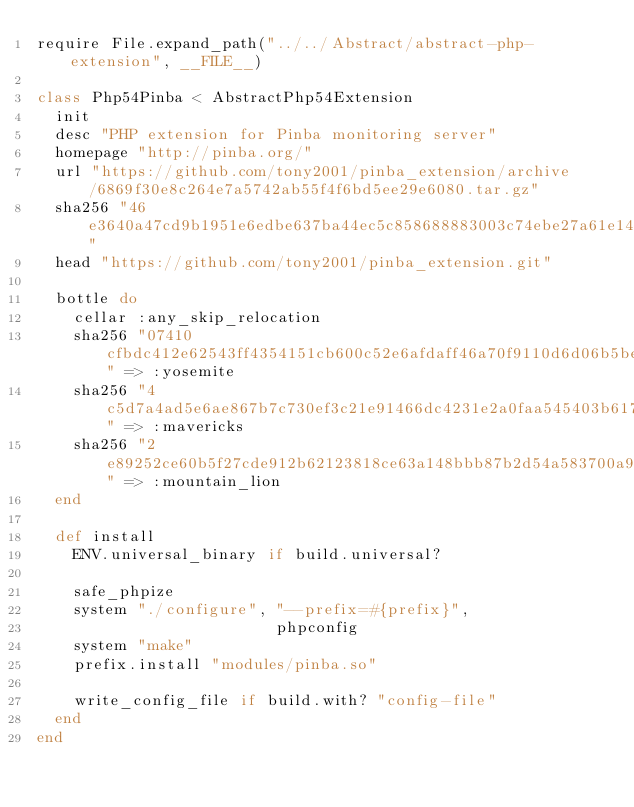<code> <loc_0><loc_0><loc_500><loc_500><_Ruby_>require File.expand_path("../../Abstract/abstract-php-extension", __FILE__)

class Php54Pinba < AbstractPhp54Extension
  init
  desc "PHP extension for Pinba monitoring server"
  homepage "http://pinba.org/"
  url "https://github.com/tony2001/pinba_extension/archive/6869f30e8c264e7a5742ab55f4f6bd5ee29e6080.tar.gz"
  sha256 "46e3640a47cd9b1951e6edbe637ba44ec5c858688883003c74ebe27a61e14fc5"
  head "https://github.com/tony2001/pinba_extension.git"

  bottle do
    cellar :any_skip_relocation
    sha256 "07410cfbdc412e62543ff4354151cb600c52e6afdaff46a70f9110d6d06b5beb" => :yosemite
    sha256 "4c5d7a4ad5e6ae867b7c730ef3c21e91466dc4231e2a0faa545403b61731ffef" => :mavericks
    sha256 "2e89252ce60b5f27cde912b62123818ce63a148bbb87b2d54a583700a9ccdf92" => :mountain_lion
  end

  def install
    ENV.universal_binary if build.universal?

    safe_phpize
    system "./configure", "--prefix=#{prefix}",
                          phpconfig
    system "make"
    prefix.install "modules/pinba.so"

    write_config_file if build.with? "config-file"
  end
end
</code> 